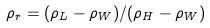Convert formula to latex. <formula><loc_0><loc_0><loc_500><loc_500>\rho _ { r } = ( \rho _ { L } - \rho _ { W } ) / ( \rho _ { H } - \rho _ { W } )</formula> 